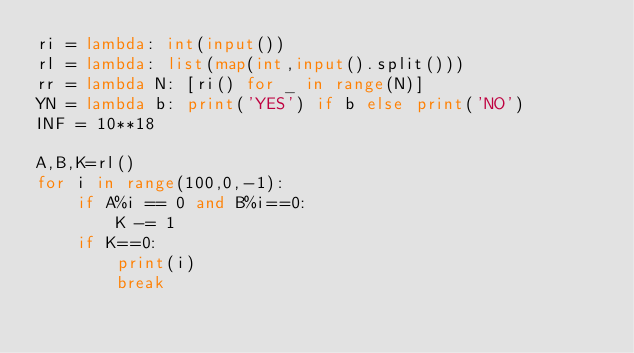Convert code to text. <code><loc_0><loc_0><loc_500><loc_500><_Python_>ri = lambda: int(input())
rl = lambda: list(map(int,input().split()))
rr = lambda N: [ri() for _ in range(N)]
YN = lambda b: print('YES') if b else print('NO')
INF = 10**18

A,B,K=rl()
for i in range(100,0,-1):
    if A%i == 0 and B%i==0:
        K -= 1
    if K==0:
        print(i)
        break</code> 